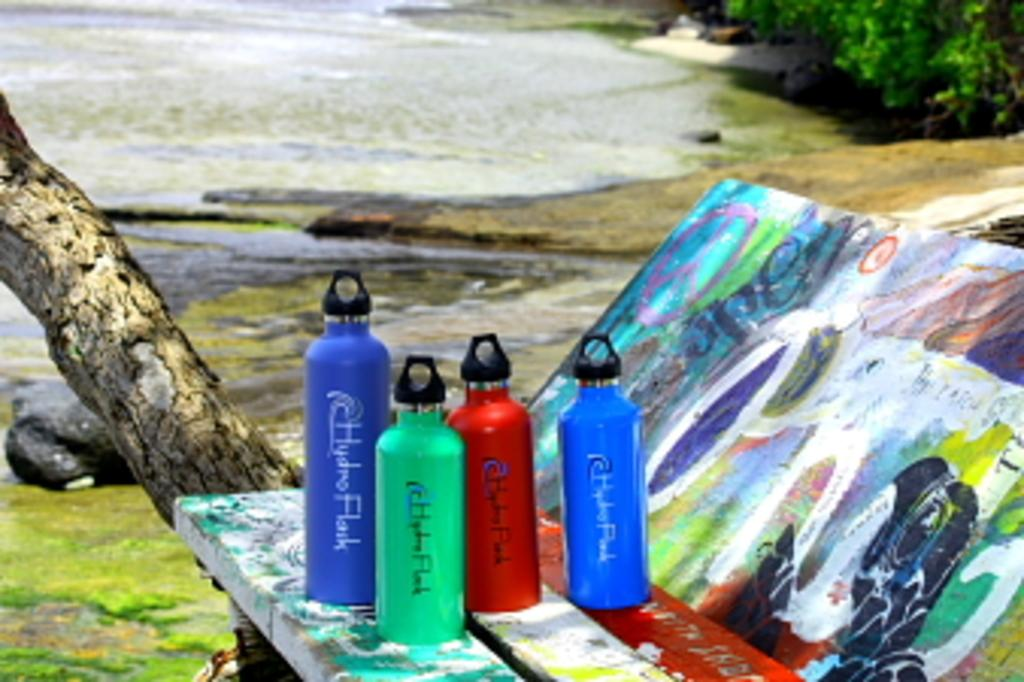What objects are present in the image? There are water bottles in the image. What colors are the water bottles? The water bottles are red, blue, and green in color. What is the surface the water bottles are placed on like? The surface the water bottles are on is colorful. What can be seen in the background of the image? There is water, trees, and the ground visible in the background of the image. What type of cloth is draped over the hill in the image? There is no hill or cloth present in the image. What kind of flower is blooming near the water in the image? There are no flowers visible in the image; only water, trees, and the ground can be seen in the background. 